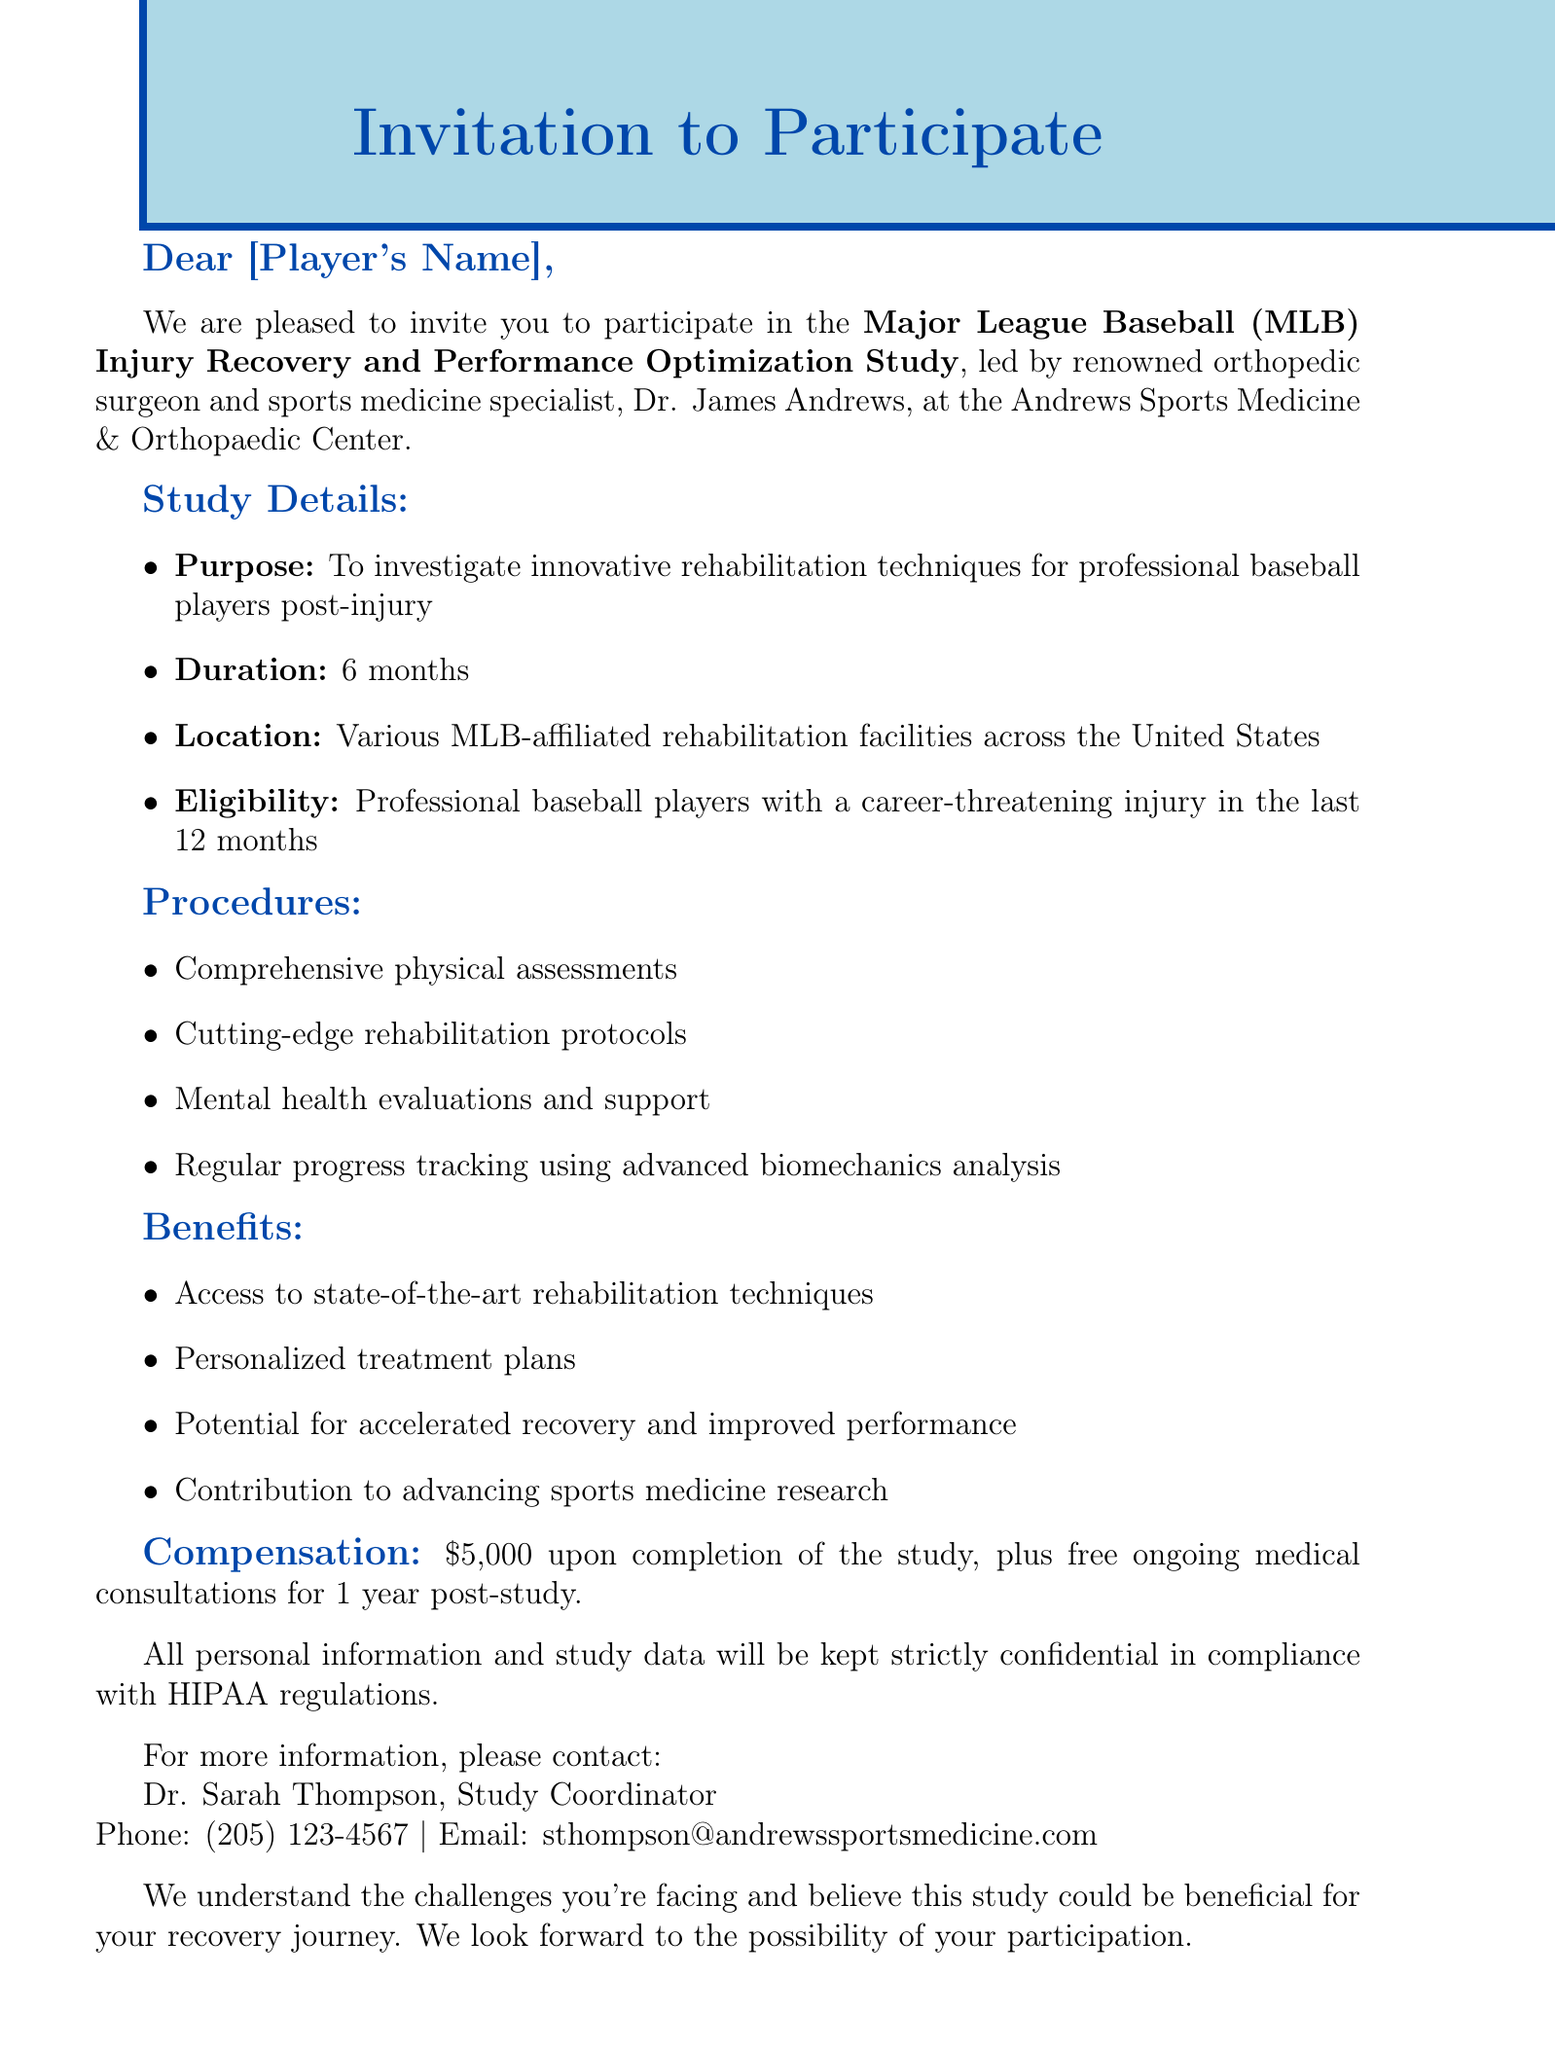What is the name of the study? The study is titled "Major League Baseball (MLB) Injury Recovery and Performance Optimization Study."
Answer: MLB Injury Recovery and Performance Optimization Study Who is the lead researcher? The lead researcher of the study is identified as Dr. James Andrews.
Answer: Dr. James Andrews How long is the duration of the study? The document states that the duration of the study is 6 months.
Answer: 6 months What is the compensation for completing the study? The document specifies a compensation amount of $5,000 upon completion of the study.
Answer: $5,000 What type of evaluations are included in the procedures? The procedures include mental health evaluations and support as one of the evaluations.
Answer: Mental health evaluations and support Is the study conducted at a single location? The document indicates that the study will take place at various MLB-affiliated rehabilitation facilities, not a single location.
Answer: Various locations What additional benefit is offered for one year post-study? The document mentions free ongoing medical consultations as an additional benefit for one year after the study.
Answer: Free ongoing medical consultations Who should be contacted for more information? The contact person for additional information is Dr. Sarah Thompson, as mentioned in the document.
Answer: Dr. Sarah Thompson 